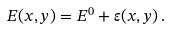<formula> <loc_0><loc_0><loc_500><loc_500>E ( x , y ) = E ^ { 0 } + \varepsilon ( x , y ) \, .</formula> 